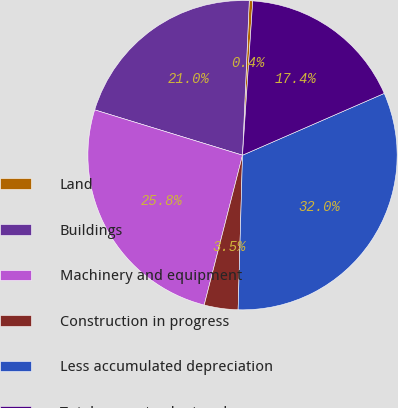Convert chart. <chart><loc_0><loc_0><loc_500><loc_500><pie_chart><fcel>Land<fcel>Buildings<fcel>Machinery and equipment<fcel>Construction in progress<fcel>Less accumulated depreciation<fcel>Total property plant and<nl><fcel>0.36%<fcel>20.96%<fcel>25.75%<fcel>3.53%<fcel>32.0%<fcel>17.4%<nl></chart> 